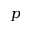<formula> <loc_0><loc_0><loc_500><loc_500>p</formula> 